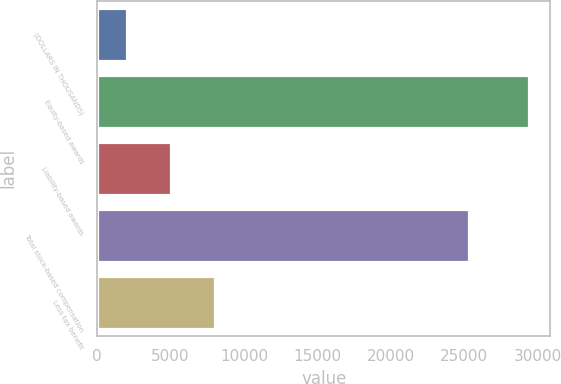Convert chart. <chart><loc_0><loc_0><loc_500><loc_500><bar_chart><fcel>(DOLLARS IN THOUSANDS)<fcel>Equity-based awards<fcel>Liability-based awards<fcel>Total stock-based compensation<fcel>Less tax benefit<nl><fcel>2018<fcel>29401<fcel>5008<fcel>25362<fcel>7998<nl></chart> 